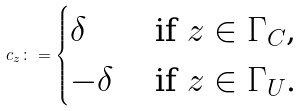Convert formula to latex. <formula><loc_0><loc_0><loc_500><loc_500>c _ { z } \colon = \begin{cases} \delta & \text { if $z \in \Gamma_{C}$,} \\ - \delta & \text { if $z \in \Gamma_{U}$.} \end{cases}</formula> 